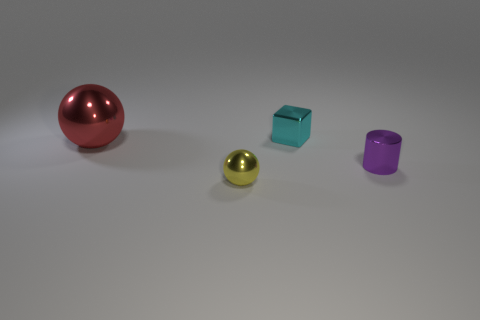What number of objects are small shiny objects in front of the purple metal thing or big green cylinders?
Your response must be concise. 1. What number of yellow objects are either shiny cubes or big spheres?
Offer a terse response. 0. How many other things are there of the same color as the metallic cylinder?
Offer a very short reply. 0. Are there fewer yellow balls that are right of the tiny yellow shiny sphere than cyan objects?
Make the answer very short. Yes. What color is the ball that is on the left side of the small yellow sphere that is to the left of the thing that is right of the tiny shiny block?
Your answer should be compact. Red. Are there any other things that have the same material as the small yellow thing?
Your response must be concise. Yes. What size is the red metallic thing that is the same shape as the small yellow metallic object?
Your response must be concise. Large. Is the number of small cylinders to the right of the tiny purple object less than the number of metallic objects in front of the small cyan metal block?
Provide a succinct answer. Yes. There is a shiny object that is left of the cyan metallic block and behind the yellow metal object; what is its shape?
Your answer should be very brief. Sphere. What size is the red object that is made of the same material as the tiny yellow thing?
Keep it short and to the point. Large. 